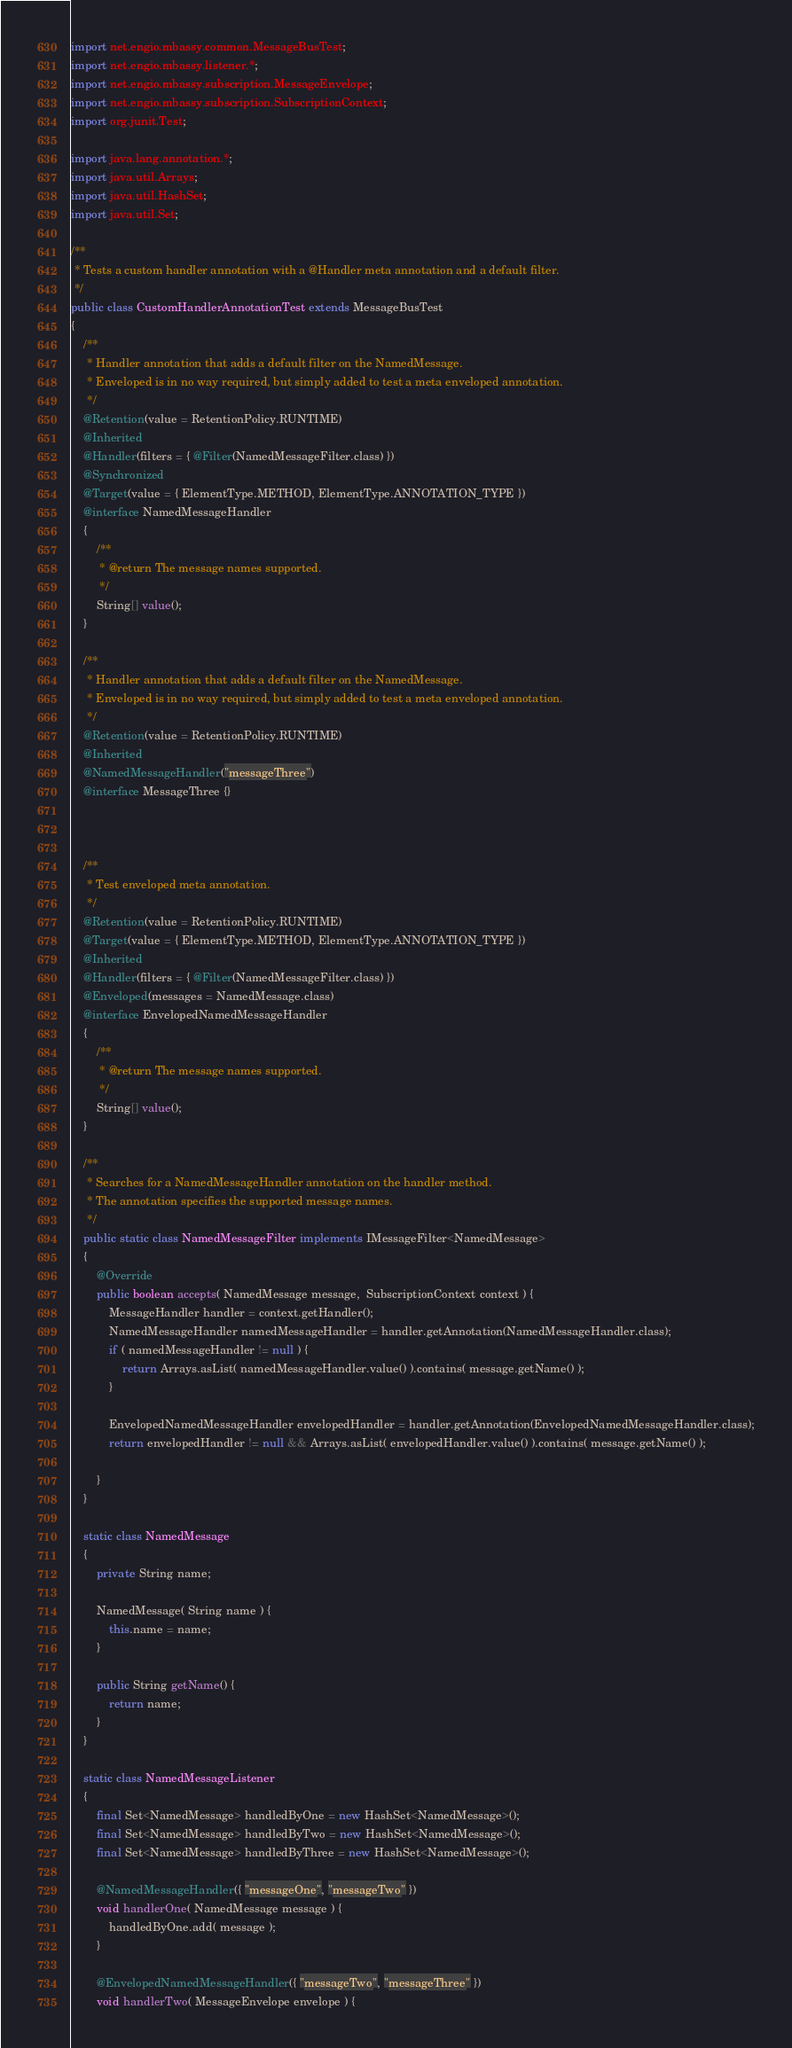<code> <loc_0><loc_0><loc_500><loc_500><_Java_>import net.engio.mbassy.common.MessageBusTest;
import net.engio.mbassy.listener.*;
import net.engio.mbassy.subscription.MessageEnvelope;
import net.engio.mbassy.subscription.SubscriptionContext;
import org.junit.Test;

import java.lang.annotation.*;
import java.util.Arrays;
import java.util.HashSet;
import java.util.Set;

/**
 * Tests a custom handler annotation with a @Handler meta annotation and a default filter.
 */
public class CustomHandlerAnnotationTest extends MessageBusTest
{
	/**
	 * Handler annotation that adds a default filter on the NamedMessage.
	 * Enveloped is in no way required, but simply added to test a meta enveloped annotation.
	 */
	@Retention(value = RetentionPolicy.RUNTIME)
	@Inherited
	@Handler(filters = { @Filter(NamedMessageFilter.class) })
	@Synchronized
	@Target(value = { ElementType.METHOD, ElementType.ANNOTATION_TYPE })
	@interface NamedMessageHandler
	{
		/**
		 * @return The message names supported.
		 */
		String[] value();
	}

    /**
     * Handler annotation that adds a default filter on the NamedMessage.
     * Enveloped is in no way required, but simply added to test a meta enveloped annotation.
     */
    @Retention(value = RetentionPolicy.RUNTIME)
    @Inherited
    @NamedMessageHandler("messageThree")
    @interface MessageThree {}



	/**
	 * Test enveloped meta annotation.
	 */
	@Retention(value = RetentionPolicy.RUNTIME)
	@Target(value = { ElementType.METHOD, ElementType.ANNOTATION_TYPE })
	@Inherited
	@Handler(filters = { @Filter(NamedMessageFilter.class) })
	@Enveloped(messages = NamedMessage.class)
	@interface EnvelopedNamedMessageHandler
	{
		/**
		 * @return The message names supported.
		 */
		String[] value();
	}

	/**
	 * Searches for a NamedMessageHandler annotation on the handler method.
	 * The annotation specifies the supported message names.
	 */
	public static class NamedMessageFilter implements IMessageFilter<NamedMessage>
	{
		@Override
		public boolean accepts( NamedMessage message,  SubscriptionContext context ) {
            MessageHandler handler = context.getHandler();
			NamedMessageHandler namedMessageHandler = handler.getAnnotation(NamedMessageHandler.class);
			if ( namedMessageHandler != null ) {
				return Arrays.asList( namedMessageHandler.value() ).contains( message.getName() );
			}

			EnvelopedNamedMessageHandler envelopedHandler = handler.getAnnotation(EnvelopedNamedMessageHandler.class);
			return envelopedHandler != null && Arrays.asList( envelopedHandler.value() ).contains( message.getName() );

		}
	}

	static class NamedMessage
	{
		private String name;

		NamedMessage( String name ) {
			this.name = name;
		}

		public String getName() {
			return name;
		}
	}

	static class NamedMessageListener
	{
		final Set<NamedMessage> handledByOne = new HashSet<NamedMessage>();
		final Set<NamedMessage> handledByTwo = new HashSet<NamedMessage>();
		final Set<NamedMessage> handledByThree = new HashSet<NamedMessage>();

		@NamedMessageHandler({ "messageOne", "messageTwo" })
		void handlerOne( NamedMessage message ) {
			handledByOne.add( message );
		}

		@EnvelopedNamedMessageHandler({ "messageTwo", "messageThree" })
		void handlerTwo( MessageEnvelope envelope ) {</code> 